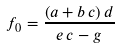<formula> <loc_0><loc_0><loc_500><loc_500>f _ { 0 } = \frac { \left ( a + b \, c \right ) d } { e \, c - g }</formula> 